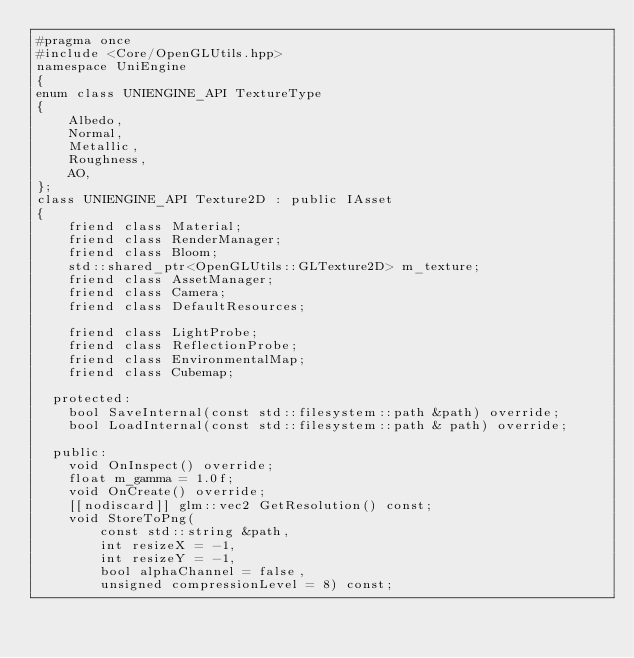Convert code to text. <code><loc_0><loc_0><loc_500><loc_500><_C++_>#pragma once
#include <Core/OpenGLUtils.hpp>
namespace UniEngine
{
enum class UNIENGINE_API TextureType
{
    Albedo,
    Normal,
    Metallic,
    Roughness,
    AO,
};
class UNIENGINE_API Texture2D : public IAsset
{
    friend class Material;
    friend class RenderManager;
    friend class Bloom;
    std::shared_ptr<OpenGLUtils::GLTexture2D> m_texture;
    friend class AssetManager;
    friend class Camera;
    friend class DefaultResources;

    friend class LightProbe;
    friend class ReflectionProbe;
    friend class EnvironmentalMap;
    friend class Cubemap;

  protected:
    bool SaveInternal(const std::filesystem::path &path) override;
    bool LoadInternal(const std::filesystem::path & path) override;

  public:
    void OnInspect() override;
    float m_gamma = 1.0f;
    void OnCreate() override;
    [[nodiscard]] glm::vec2 GetResolution() const;
    void StoreToPng(
        const std::string &path,
        int resizeX = -1,
        int resizeY = -1,
        bool alphaChannel = false,
        unsigned compressionLevel = 8) const;</code> 